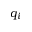<formula> <loc_0><loc_0><loc_500><loc_500>q _ { i }</formula> 